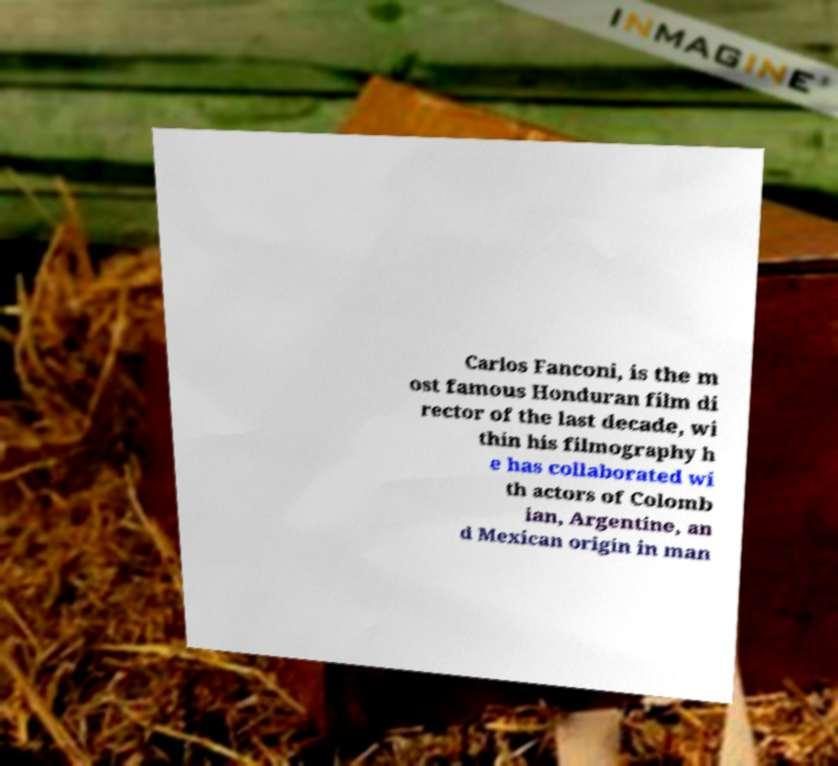There's text embedded in this image that I need extracted. Can you transcribe it verbatim? Carlos Fanconi, is the m ost famous Honduran film di rector of the last decade, wi thin his filmography h e has collaborated wi th actors of Colomb ian, Argentine, an d Mexican origin in man 